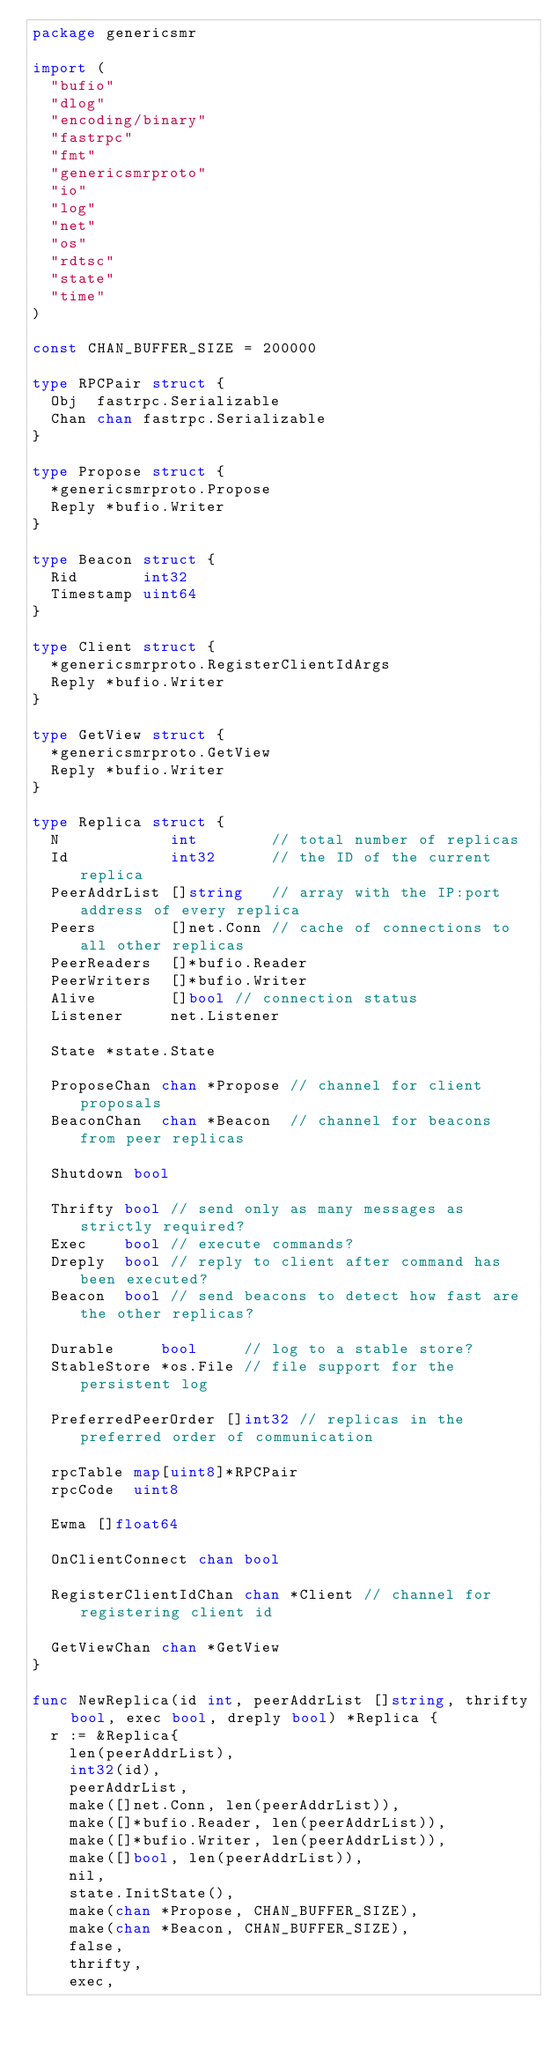<code> <loc_0><loc_0><loc_500><loc_500><_Go_>package genericsmr

import (
	"bufio"
	"dlog"
	"encoding/binary"
	"fastrpc"
	"fmt"
	"genericsmrproto"
	"io"
	"log"
	"net"
	"os"
	"rdtsc"
	"state"
	"time"
)

const CHAN_BUFFER_SIZE = 200000

type RPCPair struct {
	Obj  fastrpc.Serializable
	Chan chan fastrpc.Serializable
}

type Propose struct {
	*genericsmrproto.Propose
	Reply *bufio.Writer
}

type Beacon struct {
	Rid       int32
	Timestamp uint64
}

type Client struct {
	*genericsmrproto.RegisterClientIdArgs
	Reply *bufio.Writer
}

type GetView struct {
	*genericsmrproto.GetView
	Reply *bufio.Writer
}

type Replica struct {
	N            int        // total number of replicas
	Id           int32      // the ID of the current replica
	PeerAddrList []string   // array with the IP:port address of every replica
	Peers        []net.Conn // cache of connections to all other replicas
	PeerReaders  []*bufio.Reader
	PeerWriters  []*bufio.Writer
	Alive        []bool // connection status
	Listener     net.Listener

	State *state.State

	ProposeChan chan *Propose // channel for client proposals
	BeaconChan  chan *Beacon  // channel for beacons from peer replicas

	Shutdown bool

	Thrifty bool // send only as many messages as strictly required?
	Exec    bool // execute commands?
	Dreply  bool // reply to client after command has been executed?
	Beacon  bool // send beacons to detect how fast are the other replicas?

	Durable     bool     // log to a stable store?
	StableStore *os.File // file support for the persistent log

	PreferredPeerOrder []int32 // replicas in the preferred order of communication

	rpcTable map[uint8]*RPCPair
	rpcCode  uint8

	Ewma []float64

	OnClientConnect chan bool

	RegisterClientIdChan chan *Client // channel for registering client id

	GetViewChan chan *GetView
}

func NewReplica(id int, peerAddrList []string, thrifty bool, exec bool, dreply bool) *Replica {
	r := &Replica{
		len(peerAddrList),
		int32(id),
		peerAddrList,
		make([]net.Conn, len(peerAddrList)),
		make([]*bufio.Reader, len(peerAddrList)),
		make([]*bufio.Writer, len(peerAddrList)),
		make([]bool, len(peerAddrList)),
		nil,
		state.InitState(),
		make(chan *Propose, CHAN_BUFFER_SIZE),
		make(chan *Beacon, CHAN_BUFFER_SIZE),
		false,
		thrifty,
		exec,</code> 